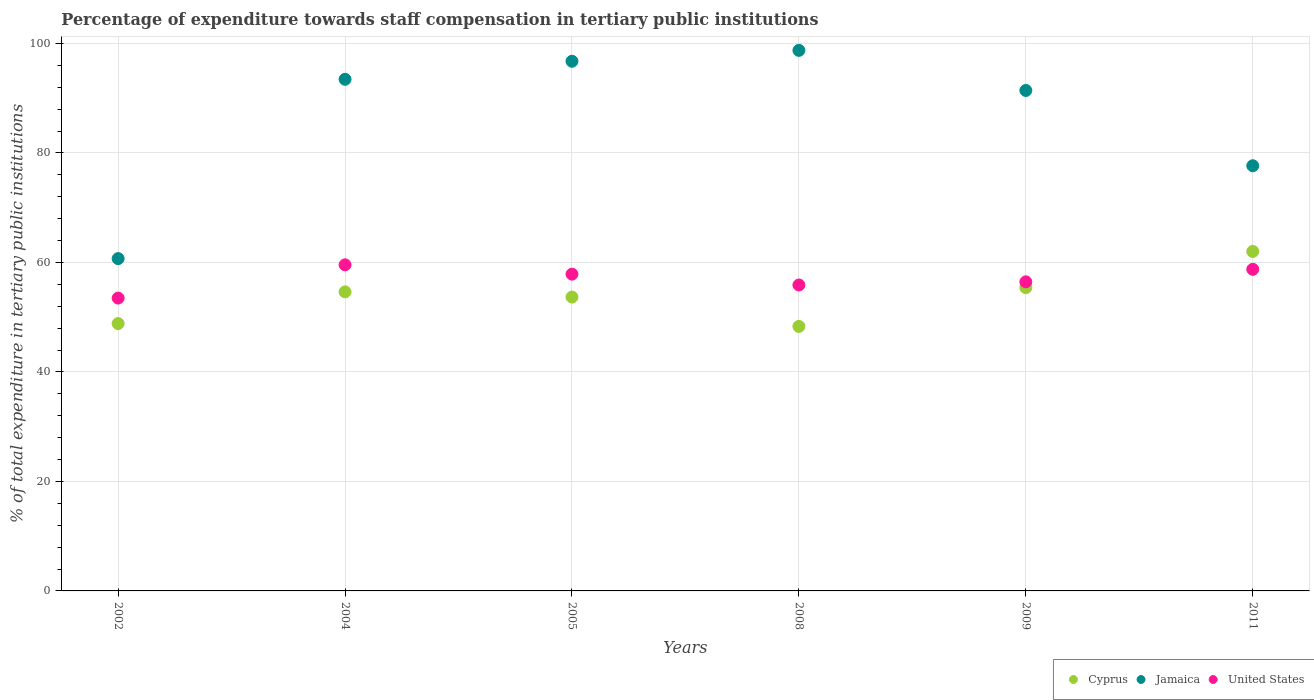How many different coloured dotlines are there?
Make the answer very short. 3. What is the percentage of expenditure towards staff compensation in Jamaica in 2008?
Ensure brevity in your answer.  98.74. Across all years, what is the maximum percentage of expenditure towards staff compensation in Cyprus?
Your answer should be compact. 62.01. Across all years, what is the minimum percentage of expenditure towards staff compensation in United States?
Ensure brevity in your answer.  53.49. In which year was the percentage of expenditure towards staff compensation in United States maximum?
Keep it short and to the point. 2004. What is the total percentage of expenditure towards staff compensation in United States in the graph?
Offer a terse response. 342. What is the difference between the percentage of expenditure towards staff compensation in Cyprus in 2004 and that in 2009?
Provide a short and direct response. -0.78. What is the difference between the percentage of expenditure towards staff compensation in Jamaica in 2008 and the percentage of expenditure towards staff compensation in United States in 2009?
Provide a short and direct response. 42.28. What is the average percentage of expenditure towards staff compensation in Cyprus per year?
Your response must be concise. 53.81. In the year 2008, what is the difference between the percentage of expenditure towards staff compensation in Cyprus and percentage of expenditure towards staff compensation in Jamaica?
Make the answer very short. -50.42. What is the ratio of the percentage of expenditure towards staff compensation in Cyprus in 2002 to that in 2008?
Your answer should be very brief. 1.01. What is the difference between the highest and the second highest percentage of expenditure towards staff compensation in Jamaica?
Your answer should be very brief. 1.99. What is the difference between the highest and the lowest percentage of expenditure towards staff compensation in United States?
Your response must be concise. 6.07. Is the percentage of expenditure towards staff compensation in Cyprus strictly greater than the percentage of expenditure towards staff compensation in United States over the years?
Your response must be concise. No. Is the percentage of expenditure towards staff compensation in Jamaica strictly less than the percentage of expenditure towards staff compensation in United States over the years?
Provide a short and direct response. No. How many dotlines are there?
Your response must be concise. 3. How many years are there in the graph?
Provide a short and direct response. 6. Are the values on the major ticks of Y-axis written in scientific E-notation?
Give a very brief answer. No. Does the graph contain any zero values?
Offer a very short reply. No. How many legend labels are there?
Your answer should be compact. 3. What is the title of the graph?
Your answer should be very brief. Percentage of expenditure towards staff compensation in tertiary public institutions. What is the label or title of the X-axis?
Your response must be concise. Years. What is the label or title of the Y-axis?
Offer a very short reply. % of total expenditure in tertiary public institutions. What is the % of total expenditure in tertiary public institutions in Cyprus in 2002?
Your response must be concise. 48.84. What is the % of total expenditure in tertiary public institutions in Jamaica in 2002?
Ensure brevity in your answer.  60.7. What is the % of total expenditure in tertiary public institutions in United States in 2002?
Your answer should be very brief. 53.49. What is the % of total expenditure in tertiary public institutions of Cyprus in 2004?
Offer a very short reply. 54.63. What is the % of total expenditure in tertiary public institutions of Jamaica in 2004?
Your answer should be very brief. 93.46. What is the % of total expenditure in tertiary public institutions of United States in 2004?
Provide a succinct answer. 59.56. What is the % of total expenditure in tertiary public institutions in Cyprus in 2005?
Provide a succinct answer. 53.68. What is the % of total expenditure in tertiary public institutions in Jamaica in 2005?
Your answer should be compact. 96.75. What is the % of total expenditure in tertiary public institutions of United States in 2005?
Offer a very short reply. 57.86. What is the % of total expenditure in tertiary public institutions of Cyprus in 2008?
Your response must be concise. 48.31. What is the % of total expenditure in tertiary public institutions in Jamaica in 2008?
Your response must be concise. 98.74. What is the % of total expenditure in tertiary public institutions of United States in 2008?
Provide a short and direct response. 55.88. What is the % of total expenditure in tertiary public institutions in Cyprus in 2009?
Ensure brevity in your answer.  55.4. What is the % of total expenditure in tertiary public institutions in Jamaica in 2009?
Provide a succinct answer. 91.41. What is the % of total expenditure in tertiary public institutions of United States in 2009?
Your answer should be compact. 56.46. What is the % of total expenditure in tertiary public institutions of Cyprus in 2011?
Make the answer very short. 62.01. What is the % of total expenditure in tertiary public institutions of Jamaica in 2011?
Offer a very short reply. 77.66. What is the % of total expenditure in tertiary public institutions in United States in 2011?
Ensure brevity in your answer.  58.74. Across all years, what is the maximum % of total expenditure in tertiary public institutions of Cyprus?
Your response must be concise. 62.01. Across all years, what is the maximum % of total expenditure in tertiary public institutions in Jamaica?
Your answer should be compact. 98.74. Across all years, what is the maximum % of total expenditure in tertiary public institutions in United States?
Give a very brief answer. 59.56. Across all years, what is the minimum % of total expenditure in tertiary public institutions in Cyprus?
Offer a terse response. 48.31. Across all years, what is the minimum % of total expenditure in tertiary public institutions in Jamaica?
Give a very brief answer. 60.7. Across all years, what is the minimum % of total expenditure in tertiary public institutions in United States?
Your answer should be compact. 53.49. What is the total % of total expenditure in tertiary public institutions of Cyprus in the graph?
Provide a short and direct response. 322.87. What is the total % of total expenditure in tertiary public institutions of Jamaica in the graph?
Ensure brevity in your answer.  518.72. What is the total % of total expenditure in tertiary public institutions in United States in the graph?
Offer a very short reply. 342. What is the difference between the % of total expenditure in tertiary public institutions of Cyprus in 2002 and that in 2004?
Ensure brevity in your answer.  -5.79. What is the difference between the % of total expenditure in tertiary public institutions of Jamaica in 2002 and that in 2004?
Make the answer very short. -32.75. What is the difference between the % of total expenditure in tertiary public institutions of United States in 2002 and that in 2004?
Ensure brevity in your answer.  -6.07. What is the difference between the % of total expenditure in tertiary public institutions in Cyprus in 2002 and that in 2005?
Your answer should be compact. -4.84. What is the difference between the % of total expenditure in tertiary public institutions in Jamaica in 2002 and that in 2005?
Provide a short and direct response. -36.05. What is the difference between the % of total expenditure in tertiary public institutions in United States in 2002 and that in 2005?
Your answer should be very brief. -4.37. What is the difference between the % of total expenditure in tertiary public institutions of Cyprus in 2002 and that in 2008?
Offer a terse response. 0.52. What is the difference between the % of total expenditure in tertiary public institutions in Jamaica in 2002 and that in 2008?
Ensure brevity in your answer.  -38.04. What is the difference between the % of total expenditure in tertiary public institutions of United States in 2002 and that in 2008?
Your answer should be very brief. -2.39. What is the difference between the % of total expenditure in tertiary public institutions of Cyprus in 2002 and that in 2009?
Make the answer very short. -6.56. What is the difference between the % of total expenditure in tertiary public institutions in Jamaica in 2002 and that in 2009?
Keep it short and to the point. -30.71. What is the difference between the % of total expenditure in tertiary public institutions of United States in 2002 and that in 2009?
Your answer should be compact. -2.96. What is the difference between the % of total expenditure in tertiary public institutions in Cyprus in 2002 and that in 2011?
Your answer should be compact. -13.18. What is the difference between the % of total expenditure in tertiary public institutions in Jamaica in 2002 and that in 2011?
Give a very brief answer. -16.96. What is the difference between the % of total expenditure in tertiary public institutions of United States in 2002 and that in 2011?
Offer a very short reply. -5.25. What is the difference between the % of total expenditure in tertiary public institutions of Cyprus in 2004 and that in 2005?
Give a very brief answer. 0.95. What is the difference between the % of total expenditure in tertiary public institutions in Jamaica in 2004 and that in 2005?
Ensure brevity in your answer.  -3.3. What is the difference between the % of total expenditure in tertiary public institutions in United States in 2004 and that in 2005?
Ensure brevity in your answer.  1.7. What is the difference between the % of total expenditure in tertiary public institutions in Cyprus in 2004 and that in 2008?
Provide a short and direct response. 6.31. What is the difference between the % of total expenditure in tertiary public institutions of Jamaica in 2004 and that in 2008?
Offer a very short reply. -5.28. What is the difference between the % of total expenditure in tertiary public institutions of United States in 2004 and that in 2008?
Ensure brevity in your answer.  3.68. What is the difference between the % of total expenditure in tertiary public institutions in Cyprus in 2004 and that in 2009?
Your answer should be compact. -0.78. What is the difference between the % of total expenditure in tertiary public institutions of Jamaica in 2004 and that in 2009?
Provide a short and direct response. 2.04. What is the difference between the % of total expenditure in tertiary public institutions in United States in 2004 and that in 2009?
Offer a terse response. 3.11. What is the difference between the % of total expenditure in tertiary public institutions in Cyprus in 2004 and that in 2011?
Your answer should be very brief. -7.39. What is the difference between the % of total expenditure in tertiary public institutions in Jamaica in 2004 and that in 2011?
Make the answer very short. 15.79. What is the difference between the % of total expenditure in tertiary public institutions in United States in 2004 and that in 2011?
Offer a terse response. 0.82. What is the difference between the % of total expenditure in tertiary public institutions in Cyprus in 2005 and that in 2008?
Your answer should be compact. 5.36. What is the difference between the % of total expenditure in tertiary public institutions in Jamaica in 2005 and that in 2008?
Offer a very short reply. -1.99. What is the difference between the % of total expenditure in tertiary public institutions of United States in 2005 and that in 2008?
Your response must be concise. 1.98. What is the difference between the % of total expenditure in tertiary public institutions in Cyprus in 2005 and that in 2009?
Provide a short and direct response. -1.72. What is the difference between the % of total expenditure in tertiary public institutions in Jamaica in 2005 and that in 2009?
Offer a terse response. 5.34. What is the difference between the % of total expenditure in tertiary public institutions in United States in 2005 and that in 2009?
Provide a succinct answer. 1.41. What is the difference between the % of total expenditure in tertiary public institutions in Cyprus in 2005 and that in 2011?
Your answer should be very brief. -8.34. What is the difference between the % of total expenditure in tertiary public institutions of Jamaica in 2005 and that in 2011?
Ensure brevity in your answer.  19.09. What is the difference between the % of total expenditure in tertiary public institutions of United States in 2005 and that in 2011?
Give a very brief answer. -0.88. What is the difference between the % of total expenditure in tertiary public institutions in Cyprus in 2008 and that in 2009?
Keep it short and to the point. -7.09. What is the difference between the % of total expenditure in tertiary public institutions in Jamaica in 2008 and that in 2009?
Keep it short and to the point. 7.32. What is the difference between the % of total expenditure in tertiary public institutions in United States in 2008 and that in 2009?
Provide a short and direct response. -0.57. What is the difference between the % of total expenditure in tertiary public institutions of Cyprus in 2008 and that in 2011?
Your answer should be very brief. -13.7. What is the difference between the % of total expenditure in tertiary public institutions in Jamaica in 2008 and that in 2011?
Give a very brief answer. 21.07. What is the difference between the % of total expenditure in tertiary public institutions in United States in 2008 and that in 2011?
Your answer should be very brief. -2.86. What is the difference between the % of total expenditure in tertiary public institutions of Cyprus in 2009 and that in 2011?
Give a very brief answer. -6.61. What is the difference between the % of total expenditure in tertiary public institutions in Jamaica in 2009 and that in 2011?
Provide a short and direct response. 13.75. What is the difference between the % of total expenditure in tertiary public institutions in United States in 2009 and that in 2011?
Your response must be concise. -2.29. What is the difference between the % of total expenditure in tertiary public institutions of Cyprus in 2002 and the % of total expenditure in tertiary public institutions of Jamaica in 2004?
Your response must be concise. -44.62. What is the difference between the % of total expenditure in tertiary public institutions in Cyprus in 2002 and the % of total expenditure in tertiary public institutions in United States in 2004?
Keep it short and to the point. -10.73. What is the difference between the % of total expenditure in tertiary public institutions in Jamaica in 2002 and the % of total expenditure in tertiary public institutions in United States in 2004?
Your response must be concise. 1.14. What is the difference between the % of total expenditure in tertiary public institutions in Cyprus in 2002 and the % of total expenditure in tertiary public institutions in Jamaica in 2005?
Give a very brief answer. -47.91. What is the difference between the % of total expenditure in tertiary public institutions of Cyprus in 2002 and the % of total expenditure in tertiary public institutions of United States in 2005?
Your answer should be very brief. -9.03. What is the difference between the % of total expenditure in tertiary public institutions in Jamaica in 2002 and the % of total expenditure in tertiary public institutions in United States in 2005?
Provide a succinct answer. 2.84. What is the difference between the % of total expenditure in tertiary public institutions in Cyprus in 2002 and the % of total expenditure in tertiary public institutions in Jamaica in 2008?
Your response must be concise. -49.9. What is the difference between the % of total expenditure in tertiary public institutions in Cyprus in 2002 and the % of total expenditure in tertiary public institutions in United States in 2008?
Your answer should be compact. -7.05. What is the difference between the % of total expenditure in tertiary public institutions in Jamaica in 2002 and the % of total expenditure in tertiary public institutions in United States in 2008?
Keep it short and to the point. 4.82. What is the difference between the % of total expenditure in tertiary public institutions in Cyprus in 2002 and the % of total expenditure in tertiary public institutions in Jamaica in 2009?
Your answer should be very brief. -42.58. What is the difference between the % of total expenditure in tertiary public institutions of Cyprus in 2002 and the % of total expenditure in tertiary public institutions of United States in 2009?
Give a very brief answer. -7.62. What is the difference between the % of total expenditure in tertiary public institutions of Jamaica in 2002 and the % of total expenditure in tertiary public institutions of United States in 2009?
Make the answer very short. 4.25. What is the difference between the % of total expenditure in tertiary public institutions in Cyprus in 2002 and the % of total expenditure in tertiary public institutions in Jamaica in 2011?
Offer a very short reply. -28.83. What is the difference between the % of total expenditure in tertiary public institutions in Cyprus in 2002 and the % of total expenditure in tertiary public institutions in United States in 2011?
Your answer should be compact. -9.91. What is the difference between the % of total expenditure in tertiary public institutions of Jamaica in 2002 and the % of total expenditure in tertiary public institutions of United States in 2011?
Ensure brevity in your answer.  1.96. What is the difference between the % of total expenditure in tertiary public institutions of Cyprus in 2004 and the % of total expenditure in tertiary public institutions of Jamaica in 2005?
Keep it short and to the point. -42.12. What is the difference between the % of total expenditure in tertiary public institutions in Cyprus in 2004 and the % of total expenditure in tertiary public institutions in United States in 2005?
Your answer should be compact. -3.24. What is the difference between the % of total expenditure in tertiary public institutions of Jamaica in 2004 and the % of total expenditure in tertiary public institutions of United States in 2005?
Your answer should be compact. 35.59. What is the difference between the % of total expenditure in tertiary public institutions in Cyprus in 2004 and the % of total expenditure in tertiary public institutions in Jamaica in 2008?
Offer a very short reply. -44.11. What is the difference between the % of total expenditure in tertiary public institutions of Cyprus in 2004 and the % of total expenditure in tertiary public institutions of United States in 2008?
Your answer should be compact. -1.26. What is the difference between the % of total expenditure in tertiary public institutions in Jamaica in 2004 and the % of total expenditure in tertiary public institutions in United States in 2008?
Your response must be concise. 37.57. What is the difference between the % of total expenditure in tertiary public institutions of Cyprus in 2004 and the % of total expenditure in tertiary public institutions of Jamaica in 2009?
Provide a short and direct response. -36.79. What is the difference between the % of total expenditure in tertiary public institutions in Cyprus in 2004 and the % of total expenditure in tertiary public institutions in United States in 2009?
Offer a terse response. -1.83. What is the difference between the % of total expenditure in tertiary public institutions in Jamaica in 2004 and the % of total expenditure in tertiary public institutions in United States in 2009?
Offer a very short reply. 37. What is the difference between the % of total expenditure in tertiary public institutions in Cyprus in 2004 and the % of total expenditure in tertiary public institutions in Jamaica in 2011?
Give a very brief answer. -23.04. What is the difference between the % of total expenditure in tertiary public institutions of Cyprus in 2004 and the % of total expenditure in tertiary public institutions of United States in 2011?
Make the answer very short. -4.12. What is the difference between the % of total expenditure in tertiary public institutions of Jamaica in 2004 and the % of total expenditure in tertiary public institutions of United States in 2011?
Make the answer very short. 34.71. What is the difference between the % of total expenditure in tertiary public institutions in Cyprus in 2005 and the % of total expenditure in tertiary public institutions in Jamaica in 2008?
Your answer should be very brief. -45.06. What is the difference between the % of total expenditure in tertiary public institutions in Cyprus in 2005 and the % of total expenditure in tertiary public institutions in United States in 2008?
Offer a very short reply. -2.21. What is the difference between the % of total expenditure in tertiary public institutions in Jamaica in 2005 and the % of total expenditure in tertiary public institutions in United States in 2008?
Make the answer very short. 40.87. What is the difference between the % of total expenditure in tertiary public institutions of Cyprus in 2005 and the % of total expenditure in tertiary public institutions of Jamaica in 2009?
Keep it short and to the point. -37.74. What is the difference between the % of total expenditure in tertiary public institutions in Cyprus in 2005 and the % of total expenditure in tertiary public institutions in United States in 2009?
Provide a short and direct response. -2.78. What is the difference between the % of total expenditure in tertiary public institutions in Jamaica in 2005 and the % of total expenditure in tertiary public institutions in United States in 2009?
Offer a terse response. 40.3. What is the difference between the % of total expenditure in tertiary public institutions in Cyprus in 2005 and the % of total expenditure in tertiary public institutions in Jamaica in 2011?
Provide a short and direct response. -23.99. What is the difference between the % of total expenditure in tertiary public institutions in Cyprus in 2005 and the % of total expenditure in tertiary public institutions in United States in 2011?
Ensure brevity in your answer.  -5.07. What is the difference between the % of total expenditure in tertiary public institutions of Jamaica in 2005 and the % of total expenditure in tertiary public institutions of United States in 2011?
Ensure brevity in your answer.  38.01. What is the difference between the % of total expenditure in tertiary public institutions in Cyprus in 2008 and the % of total expenditure in tertiary public institutions in Jamaica in 2009?
Keep it short and to the point. -43.1. What is the difference between the % of total expenditure in tertiary public institutions of Cyprus in 2008 and the % of total expenditure in tertiary public institutions of United States in 2009?
Keep it short and to the point. -8.14. What is the difference between the % of total expenditure in tertiary public institutions of Jamaica in 2008 and the % of total expenditure in tertiary public institutions of United States in 2009?
Keep it short and to the point. 42.28. What is the difference between the % of total expenditure in tertiary public institutions in Cyprus in 2008 and the % of total expenditure in tertiary public institutions in Jamaica in 2011?
Give a very brief answer. -29.35. What is the difference between the % of total expenditure in tertiary public institutions of Cyprus in 2008 and the % of total expenditure in tertiary public institutions of United States in 2011?
Keep it short and to the point. -10.43. What is the difference between the % of total expenditure in tertiary public institutions of Jamaica in 2008 and the % of total expenditure in tertiary public institutions of United States in 2011?
Provide a short and direct response. 39.99. What is the difference between the % of total expenditure in tertiary public institutions in Cyprus in 2009 and the % of total expenditure in tertiary public institutions in Jamaica in 2011?
Provide a succinct answer. -22.26. What is the difference between the % of total expenditure in tertiary public institutions of Cyprus in 2009 and the % of total expenditure in tertiary public institutions of United States in 2011?
Your answer should be compact. -3.34. What is the difference between the % of total expenditure in tertiary public institutions of Jamaica in 2009 and the % of total expenditure in tertiary public institutions of United States in 2011?
Offer a very short reply. 32.67. What is the average % of total expenditure in tertiary public institutions of Cyprus per year?
Your answer should be very brief. 53.81. What is the average % of total expenditure in tertiary public institutions of Jamaica per year?
Ensure brevity in your answer.  86.45. What is the average % of total expenditure in tertiary public institutions in United States per year?
Provide a succinct answer. 57. In the year 2002, what is the difference between the % of total expenditure in tertiary public institutions of Cyprus and % of total expenditure in tertiary public institutions of Jamaica?
Give a very brief answer. -11.86. In the year 2002, what is the difference between the % of total expenditure in tertiary public institutions in Cyprus and % of total expenditure in tertiary public institutions in United States?
Offer a very short reply. -4.65. In the year 2002, what is the difference between the % of total expenditure in tertiary public institutions in Jamaica and % of total expenditure in tertiary public institutions in United States?
Ensure brevity in your answer.  7.21. In the year 2004, what is the difference between the % of total expenditure in tertiary public institutions in Cyprus and % of total expenditure in tertiary public institutions in Jamaica?
Make the answer very short. -38.83. In the year 2004, what is the difference between the % of total expenditure in tertiary public institutions in Cyprus and % of total expenditure in tertiary public institutions in United States?
Your answer should be compact. -4.94. In the year 2004, what is the difference between the % of total expenditure in tertiary public institutions in Jamaica and % of total expenditure in tertiary public institutions in United States?
Your response must be concise. 33.89. In the year 2005, what is the difference between the % of total expenditure in tertiary public institutions in Cyprus and % of total expenditure in tertiary public institutions in Jamaica?
Your response must be concise. -43.07. In the year 2005, what is the difference between the % of total expenditure in tertiary public institutions in Cyprus and % of total expenditure in tertiary public institutions in United States?
Keep it short and to the point. -4.19. In the year 2005, what is the difference between the % of total expenditure in tertiary public institutions in Jamaica and % of total expenditure in tertiary public institutions in United States?
Make the answer very short. 38.89. In the year 2008, what is the difference between the % of total expenditure in tertiary public institutions of Cyprus and % of total expenditure in tertiary public institutions of Jamaica?
Ensure brevity in your answer.  -50.42. In the year 2008, what is the difference between the % of total expenditure in tertiary public institutions in Cyprus and % of total expenditure in tertiary public institutions in United States?
Make the answer very short. -7.57. In the year 2008, what is the difference between the % of total expenditure in tertiary public institutions of Jamaica and % of total expenditure in tertiary public institutions of United States?
Your answer should be compact. 42.85. In the year 2009, what is the difference between the % of total expenditure in tertiary public institutions of Cyprus and % of total expenditure in tertiary public institutions of Jamaica?
Your answer should be compact. -36.01. In the year 2009, what is the difference between the % of total expenditure in tertiary public institutions in Cyprus and % of total expenditure in tertiary public institutions in United States?
Keep it short and to the point. -1.05. In the year 2009, what is the difference between the % of total expenditure in tertiary public institutions of Jamaica and % of total expenditure in tertiary public institutions of United States?
Keep it short and to the point. 34.96. In the year 2011, what is the difference between the % of total expenditure in tertiary public institutions of Cyprus and % of total expenditure in tertiary public institutions of Jamaica?
Your answer should be compact. -15.65. In the year 2011, what is the difference between the % of total expenditure in tertiary public institutions of Cyprus and % of total expenditure in tertiary public institutions of United States?
Make the answer very short. 3.27. In the year 2011, what is the difference between the % of total expenditure in tertiary public institutions of Jamaica and % of total expenditure in tertiary public institutions of United States?
Keep it short and to the point. 18.92. What is the ratio of the % of total expenditure in tertiary public institutions in Cyprus in 2002 to that in 2004?
Keep it short and to the point. 0.89. What is the ratio of the % of total expenditure in tertiary public institutions in Jamaica in 2002 to that in 2004?
Provide a short and direct response. 0.65. What is the ratio of the % of total expenditure in tertiary public institutions in United States in 2002 to that in 2004?
Offer a very short reply. 0.9. What is the ratio of the % of total expenditure in tertiary public institutions of Cyprus in 2002 to that in 2005?
Your answer should be very brief. 0.91. What is the ratio of the % of total expenditure in tertiary public institutions of Jamaica in 2002 to that in 2005?
Your answer should be very brief. 0.63. What is the ratio of the % of total expenditure in tertiary public institutions of United States in 2002 to that in 2005?
Your answer should be compact. 0.92. What is the ratio of the % of total expenditure in tertiary public institutions in Cyprus in 2002 to that in 2008?
Make the answer very short. 1.01. What is the ratio of the % of total expenditure in tertiary public institutions of Jamaica in 2002 to that in 2008?
Make the answer very short. 0.61. What is the ratio of the % of total expenditure in tertiary public institutions in United States in 2002 to that in 2008?
Give a very brief answer. 0.96. What is the ratio of the % of total expenditure in tertiary public institutions of Cyprus in 2002 to that in 2009?
Offer a terse response. 0.88. What is the ratio of the % of total expenditure in tertiary public institutions of Jamaica in 2002 to that in 2009?
Give a very brief answer. 0.66. What is the ratio of the % of total expenditure in tertiary public institutions of United States in 2002 to that in 2009?
Provide a short and direct response. 0.95. What is the ratio of the % of total expenditure in tertiary public institutions of Cyprus in 2002 to that in 2011?
Provide a short and direct response. 0.79. What is the ratio of the % of total expenditure in tertiary public institutions of Jamaica in 2002 to that in 2011?
Give a very brief answer. 0.78. What is the ratio of the % of total expenditure in tertiary public institutions in United States in 2002 to that in 2011?
Keep it short and to the point. 0.91. What is the ratio of the % of total expenditure in tertiary public institutions in Cyprus in 2004 to that in 2005?
Your answer should be very brief. 1.02. What is the ratio of the % of total expenditure in tertiary public institutions in Jamaica in 2004 to that in 2005?
Provide a succinct answer. 0.97. What is the ratio of the % of total expenditure in tertiary public institutions of United States in 2004 to that in 2005?
Make the answer very short. 1.03. What is the ratio of the % of total expenditure in tertiary public institutions in Cyprus in 2004 to that in 2008?
Offer a very short reply. 1.13. What is the ratio of the % of total expenditure in tertiary public institutions of Jamaica in 2004 to that in 2008?
Ensure brevity in your answer.  0.95. What is the ratio of the % of total expenditure in tertiary public institutions in United States in 2004 to that in 2008?
Give a very brief answer. 1.07. What is the ratio of the % of total expenditure in tertiary public institutions in Jamaica in 2004 to that in 2009?
Give a very brief answer. 1.02. What is the ratio of the % of total expenditure in tertiary public institutions in United States in 2004 to that in 2009?
Your response must be concise. 1.06. What is the ratio of the % of total expenditure in tertiary public institutions in Cyprus in 2004 to that in 2011?
Ensure brevity in your answer.  0.88. What is the ratio of the % of total expenditure in tertiary public institutions of Jamaica in 2004 to that in 2011?
Your answer should be compact. 1.2. What is the ratio of the % of total expenditure in tertiary public institutions of Cyprus in 2005 to that in 2008?
Provide a short and direct response. 1.11. What is the ratio of the % of total expenditure in tertiary public institutions in Jamaica in 2005 to that in 2008?
Give a very brief answer. 0.98. What is the ratio of the % of total expenditure in tertiary public institutions of United States in 2005 to that in 2008?
Provide a succinct answer. 1.04. What is the ratio of the % of total expenditure in tertiary public institutions of Cyprus in 2005 to that in 2009?
Your answer should be compact. 0.97. What is the ratio of the % of total expenditure in tertiary public institutions in Jamaica in 2005 to that in 2009?
Your answer should be very brief. 1.06. What is the ratio of the % of total expenditure in tertiary public institutions in United States in 2005 to that in 2009?
Your answer should be compact. 1.02. What is the ratio of the % of total expenditure in tertiary public institutions in Cyprus in 2005 to that in 2011?
Give a very brief answer. 0.87. What is the ratio of the % of total expenditure in tertiary public institutions of Jamaica in 2005 to that in 2011?
Provide a succinct answer. 1.25. What is the ratio of the % of total expenditure in tertiary public institutions of United States in 2005 to that in 2011?
Keep it short and to the point. 0.98. What is the ratio of the % of total expenditure in tertiary public institutions in Cyprus in 2008 to that in 2009?
Provide a succinct answer. 0.87. What is the ratio of the % of total expenditure in tertiary public institutions in Jamaica in 2008 to that in 2009?
Make the answer very short. 1.08. What is the ratio of the % of total expenditure in tertiary public institutions of United States in 2008 to that in 2009?
Ensure brevity in your answer.  0.99. What is the ratio of the % of total expenditure in tertiary public institutions of Cyprus in 2008 to that in 2011?
Your answer should be compact. 0.78. What is the ratio of the % of total expenditure in tertiary public institutions of Jamaica in 2008 to that in 2011?
Give a very brief answer. 1.27. What is the ratio of the % of total expenditure in tertiary public institutions in United States in 2008 to that in 2011?
Offer a very short reply. 0.95. What is the ratio of the % of total expenditure in tertiary public institutions in Cyprus in 2009 to that in 2011?
Provide a short and direct response. 0.89. What is the ratio of the % of total expenditure in tertiary public institutions in Jamaica in 2009 to that in 2011?
Your response must be concise. 1.18. What is the ratio of the % of total expenditure in tertiary public institutions in United States in 2009 to that in 2011?
Ensure brevity in your answer.  0.96. What is the difference between the highest and the second highest % of total expenditure in tertiary public institutions in Cyprus?
Keep it short and to the point. 6.61. What is the difference between the highest and the second highest % of total expenditure in tertiary public institutions in Jamaica?
Give a very brief answer. 1.99. What is the difference between the highest and the second highest % of total expenditure in tertiary public institutions of United States?
Provide a short and direct response. 0.82. What is the difference between the highest and the lowest % of total expenditure in tertiary public institutions in Cyprus?
Provide a succinct answer. 13.7. What is the difference between the highest and the lowest % of total expenditure in tertiary public institutions in Jamaica?
Make the answer very short. 38.04. What is the difference between the highest and the lowest % of total expenditure in tertiary public institutions of United States?
Keep it short and to the point. 6.07. 